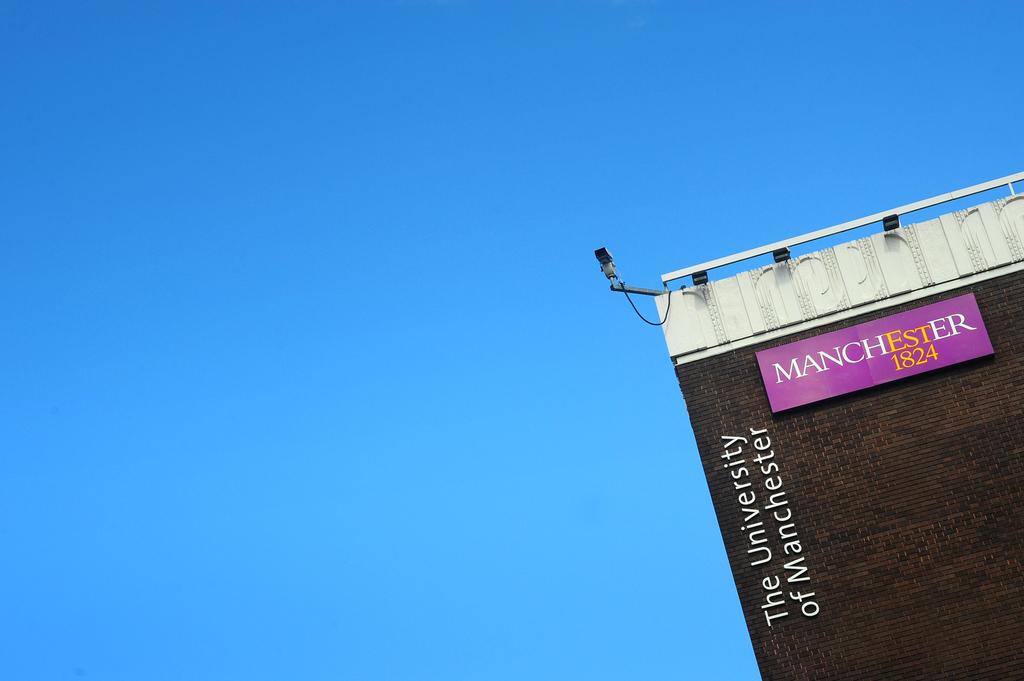What university is this?
Provide a short and direct response. Manchester. What year is displayed?
Ensure brevity in your answer.  1824. 